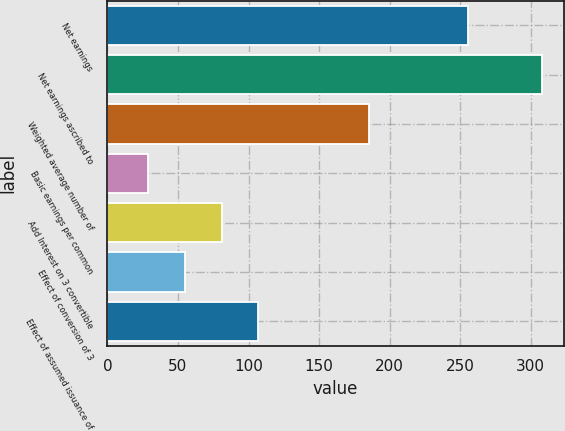Convert chart. <chart><loc_0><loc_0><loc_500><loc_500><bar_chart><fcel>Net earnings<fcel>Net earnings ascribed to<fcel>Weighted average number of<fcel>Basic earnings per common<fcel>Add Interest on 3 convertible<fcel>Effect of conversion of 3<fcel>Effect of assumed issuance of<nl><fcel>255.8<fcel>307.98<fcel>185.32<fcel>28.78<fcel>80.96<fcel>54.87<fcel>107.05<nl></chart> 